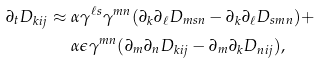<formula> <loc_0><loc_0><loc_500><loc_500>\partial _ { t } D _ { k i j } \approx & \ \alpha \gamma ^ { \ell s } \gamma ^ { m n } ( \partial _ { k } \partial _ { \ell } D _ { m s n } - \partial _ { k } \partial _ { \ell } D _ { s m n } ) + \\ & \ \alpha \epsilon \gamma ^ { m n } ( \partial _ { m } \partial _ { n } D _ { k i j } - \partial _ { m } \partial _ { k } D _ { n i j } ) ,</formula> 